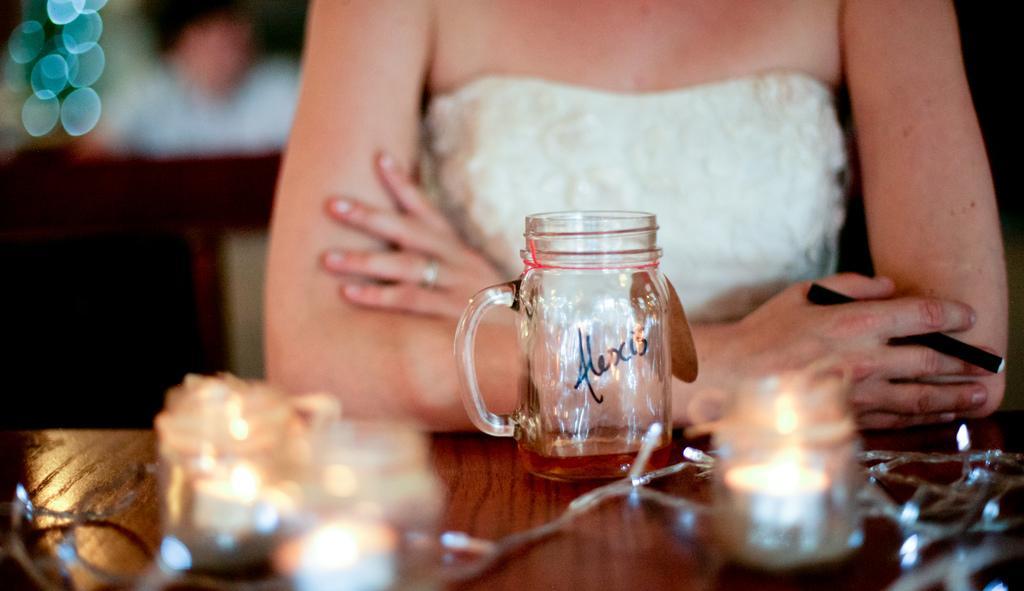In one or two sentences, can you explain what this image depicts? In this picture there is a women who is in white dress, In front of the women there there is a table on the table there is a glass jar, spoon and woman is holding something which is in black color. Background of the woman is blur. 